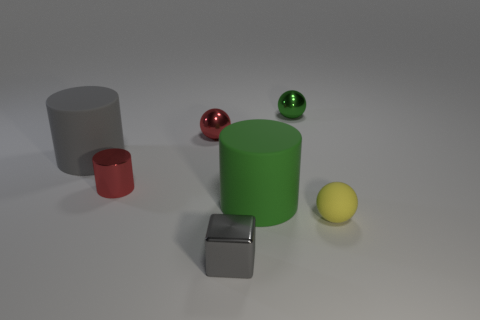Is there any other thing that is the same shape as the gray metallic thing?
Your response must be concise. No. There is a tiny ball that is the same material as the green cylinder; what color is it?
Keep it short and to the point. Yellow. What number of objects are gray objects or large red rubber things?
Ensure brevity in your answer.  2. There is a block; is its size the same as the ball that is left of the green sphere?
Offer a very short reply. Yes. There is a tiny ball in front of the large cylinder left of the shiny ball that is to the left of the tiny green metal thing; what is its color?
Your answer should be compact. Yellow. The block is what color?
Provide a succinct answer. Gray. Are there more tiny green shiny objects that are behind the tiny green ball than big gray cylinders that are right of the big green matte object?
Ensure brevity in your answer.  No. Does the big gray matte thing have the same shape as the metallic thing to the right of the green rubber thing?
Ensure brevity in your answer.  No. Is the size of the gray object that is to the left of the tiny gray shiny block the same as the gray thing that is in front of the yellow matte ball?
Your answer should be very brief. No. Are there any shiny spheres that are on the left side of the small red metallic cylinder that is left of the small ball on the right side of the small green shiny object?
Your answer should be very brief. No. 